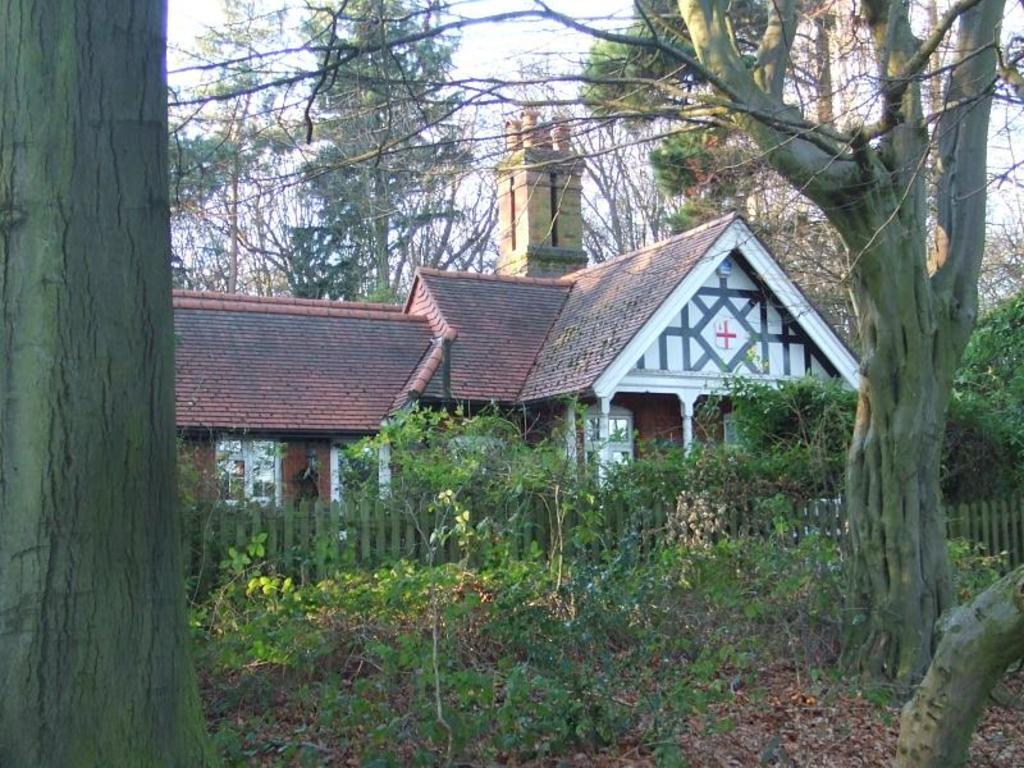What type of vegetation can be seen in the image? There are trees and plants in the image. What type of structure is visible in the image? There is a house in the image. What feature can be seen near the house? There is a railing in the image. What part of the natural environment is visible in the image? The sky is visible in the image. What type of button can be seen on the street in the image? There is no button or street present in the image. What type of thunder can be heard in the image? There is no thunder present in the image, as it is a visual medium. 